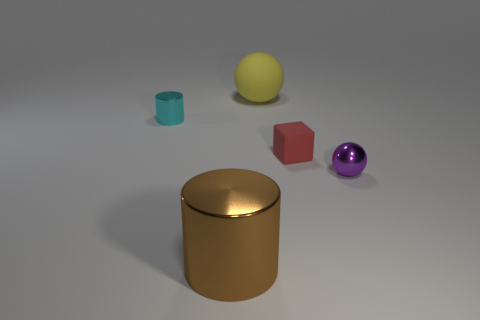How does the lighting in the image affect the appearance of the objects? The lighting in the image is diffuse, softening shadows and giving the objects a gentle appearance. It highlights the reflective properties of the glossy cylinder and sphere, while the matte surfaces of the cube and small cylinder absorb the light, reducing reflections and making their colors appear more saturated.  Which of these objects seem out of place considering their surroundings? Considering the arrangement, none of the objects seem particularly out of place as they all share a simplicity in shape and are evenly spaced. However, if we are to choose one, the purple sphere might be considered slightly out of place due to its vibrant color which stands out among the more subdued tones of the other objects. 